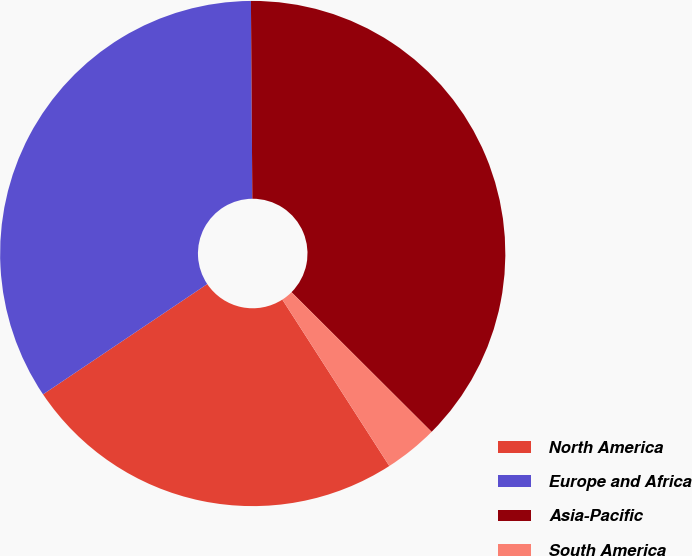Convert chart to OTSL. <chart><loc_0><loc_0><loc_500><loc_500><pie_chart><fcel>North America<fcel>Europe and Africa<fcel>Asia-Pacific<fcel>South America<nl><fcel>24.68%<fcel>34.3%<fcel>37.59%<fcel>3.43%<nl></chart> 